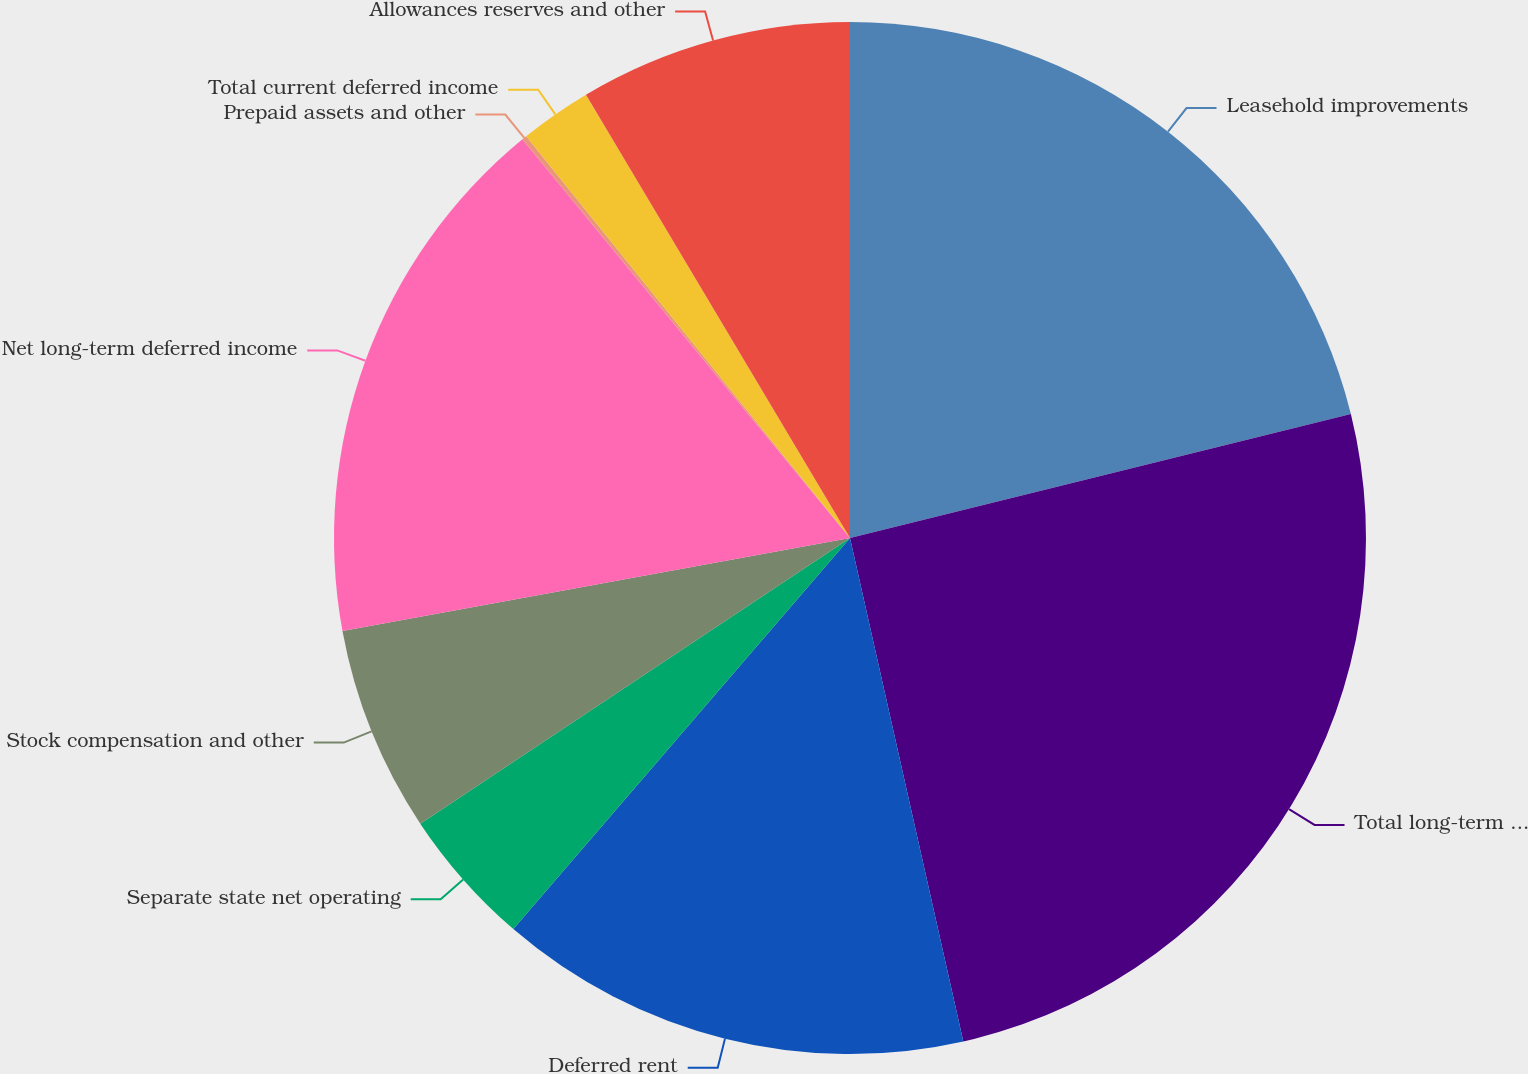<chart> <loc_0><loc_0><loc_500><loc_500><pie_chart><fcel>Leasehold improvements<fcel>Total long-term deferred<fcel>Deferred rent<fcel>Separate state net operating<fcel>Stock compensation and other<fcel>Net long-term deferred income<fcel>Prepaid assets and other<fcel>Total current deferred income<fcel>Allowances reserves and other<nl><fcel>21.14%<fcel>25.34%<fcel>14.84%<fcel>4.35%<fcel>6.45%<fcel>16.94%<fcel>0.15%<fcel>2.25%<fcel>8.55%<nl></chart> 